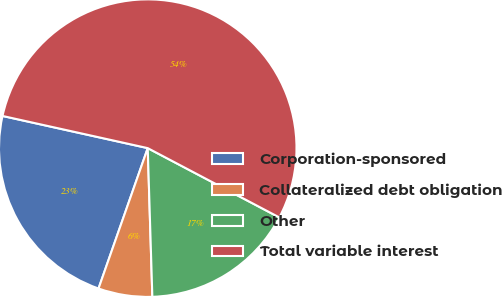Convert chart to OTSL. <chart><loc_0><loc_0><loc_500><loc_500><pie_chart><fcel>Corporation-sponsored<fcel>Collateralized debt obligation<fcel>Other<fcel>Total variable interest<nl><fcel>23.1%<fcel>5.86%<fcel>16.79%<fcel>54.24%<nl></chart> 